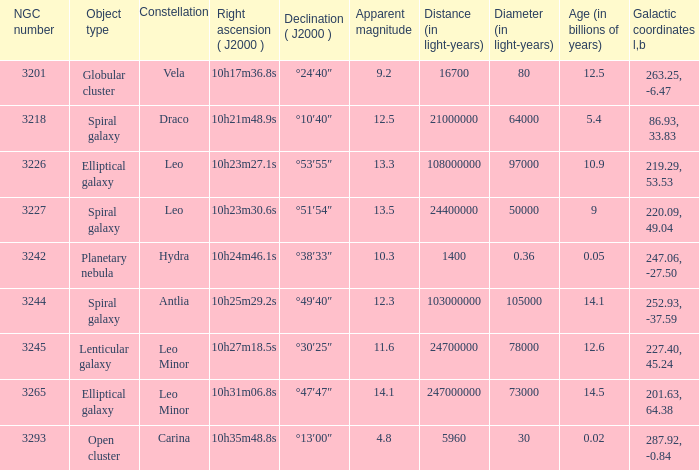What is the total of Apparent magnitudes for an NGC number larger than 3293? None. 